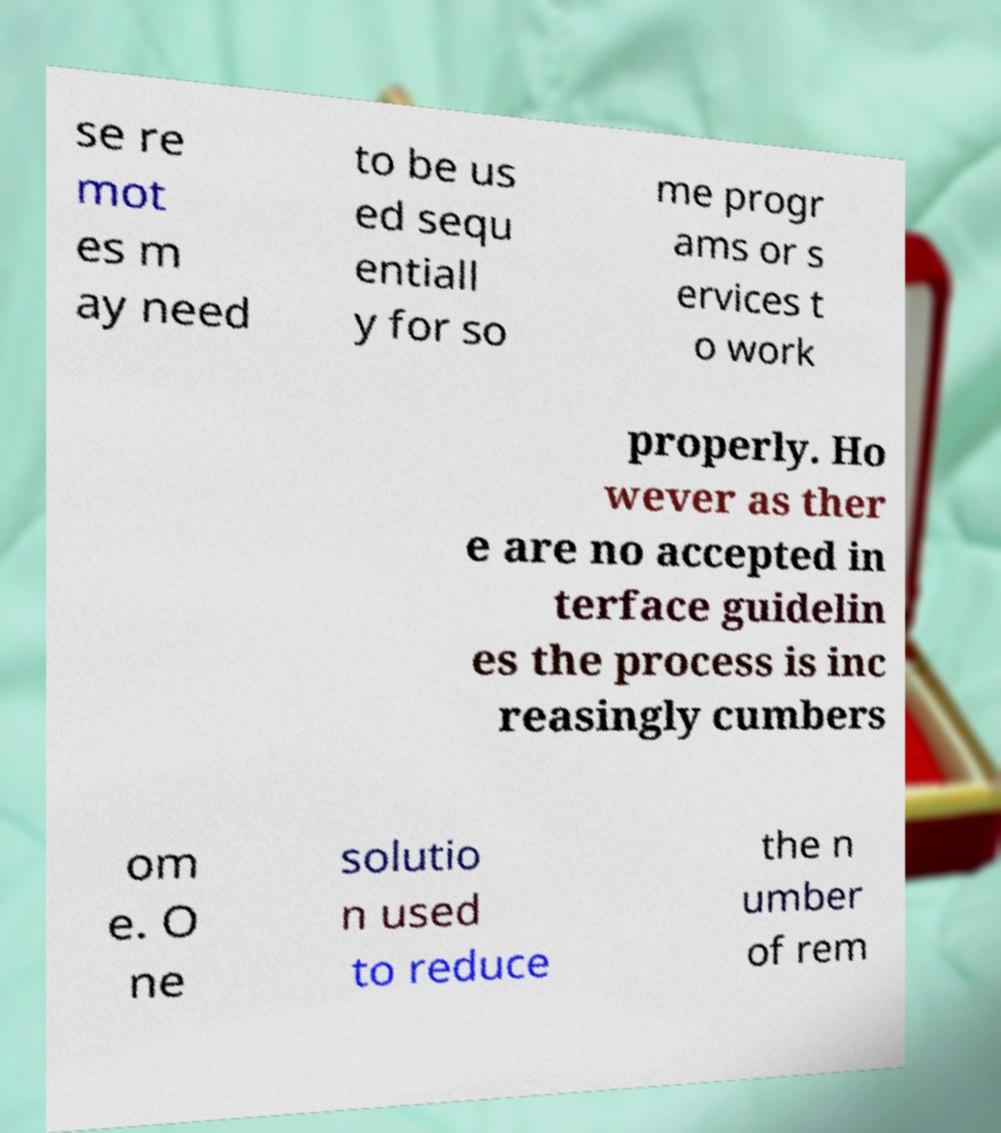Could you extract and type out the text from this image? se re mot es m ay need to be us ed sequ entiall y for so me progr ams or s ervices t o work properly. Ho wever as ther e are no accepted in terface guidelin es the process is inc reasingly cumbers om e. O ne solutio n used to reduce the n umber of rem 